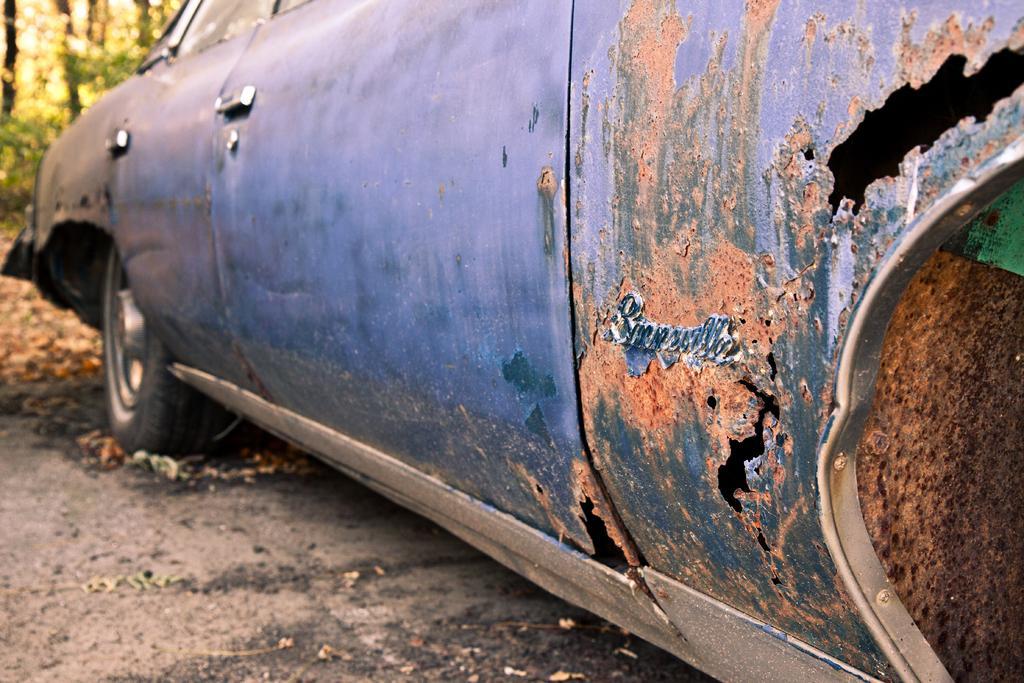Can you describe this image briefly? In this image we can see an old car on the road. In the background there are trees. 